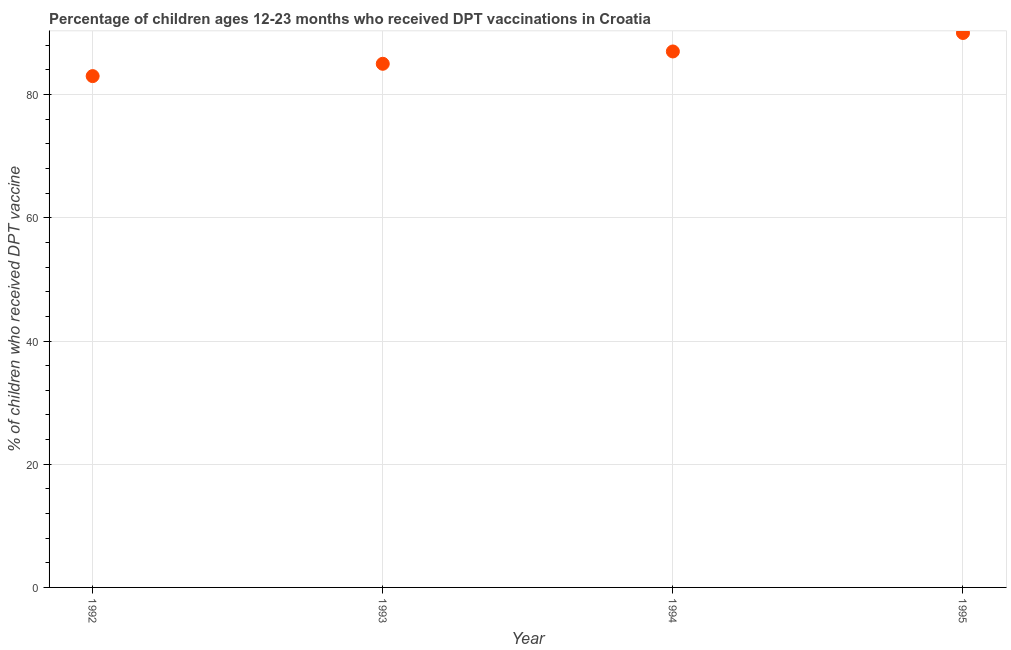What is the percentage of children who received dpt vaccine in 1993?
Make the answer very short. 85. Across all years, what is the maximum percentage of children who received dpt vaccine?
Make the answer very short. 90. Across all years, what is the minimum percentage of children who received dpt vaccine?
Offer a very short reply. 83. In which year was the percentage of children who received dpt vaccine maximum?
Your response must be concise. 1995. What is the sum of the percentage of children who received dpt vaccine?
Offer a very short reply. 345. What is the difference between the percentage of children who received dpt vaccine in 1993 and 1995?
Make the answer very short. -5. What is the average percentage of children who received dpt vaccine per year?
Your response must be concise. 86.25. In how many years, is the percentage of children who received dpt vaccine greater than 28 %?
Provide a succinct answer. 4. Do a majority of the years between 1993 and 1994 (inclusive) have percentage of children who received dpt vaccine greater than 48 %?
Your answer should be very brief. Yes. What is the ratio of the percentage of children who received dpt vaccine in 1993 to that in 1994?
Offer a very short reply. 0.98. Is the difference between the percentage of children who received dpt vaccine in 1992 and 1993 greater than the difference between any two years?
Keep it short and to the point. No. Is the sum of the percentage of children who received dpt vaccine in 1992 and 1993 greater than the maximum percentage of children who received dpt vaccine across all years?
Ensure brevity in your answer.  Yes. What is the difference between the highest and the lowest percentage of children who received dpt vaccine?
Offer a very short reply. 7. Does the percentage of children who received dpt vaccine monotonically increase over the years?
Keep it short and to the point. Yes. How many dotlines are there?
Ensure brevity in your answer.  1. What is the difference between two consecutive major ticks on the Y-axis?
Your answer should be very brief. 20. Does the graph contain any zero values?
Provide a short and direct response. No. What is the title of the graph?
Provide a succinct answer. Percentage of children ages 12-23 months who received DPT vaccinations in Croatia. What is the label or title of the Y-axis?
Your answer should be very brief. % of children who received DPT vaccine. What is the % of children who received DPT vaccine in 1993?
Provide a succinct answer. 85. What is the % of children who received DPT vaccine in 1994?
Ensure brevity in your answer.  87. What is the difference between the % of children who received DPT vaccine in 1992 and 1994?
Your response must be concise. -4. What is the difference between the % of children who received DPT vaccine in 1993 and 1994?
Your answer should be very brief. -2. What is the difference between the % of children who received DPT vaccine in 1994 and 1995?
Keep it short and to the point. -3. What is the ratio of the % of children who received DPT vaccine in 1992 to that in 1993?
Keep it short and to the point. 0.98. What is the ratio of the % of children who received DPT vaccine in 1992 to that in 1994?
Provide a succinct answer. 0.95. What is the ratio of the % of children who received DPT vaccine in 1992 to that in 1995?
Keep it short and to the point. 0.92. What is the ratio of the % of children who received DPT vaccine in 1993 to that in 1995?
Your answer should be very brief. 0.94. 